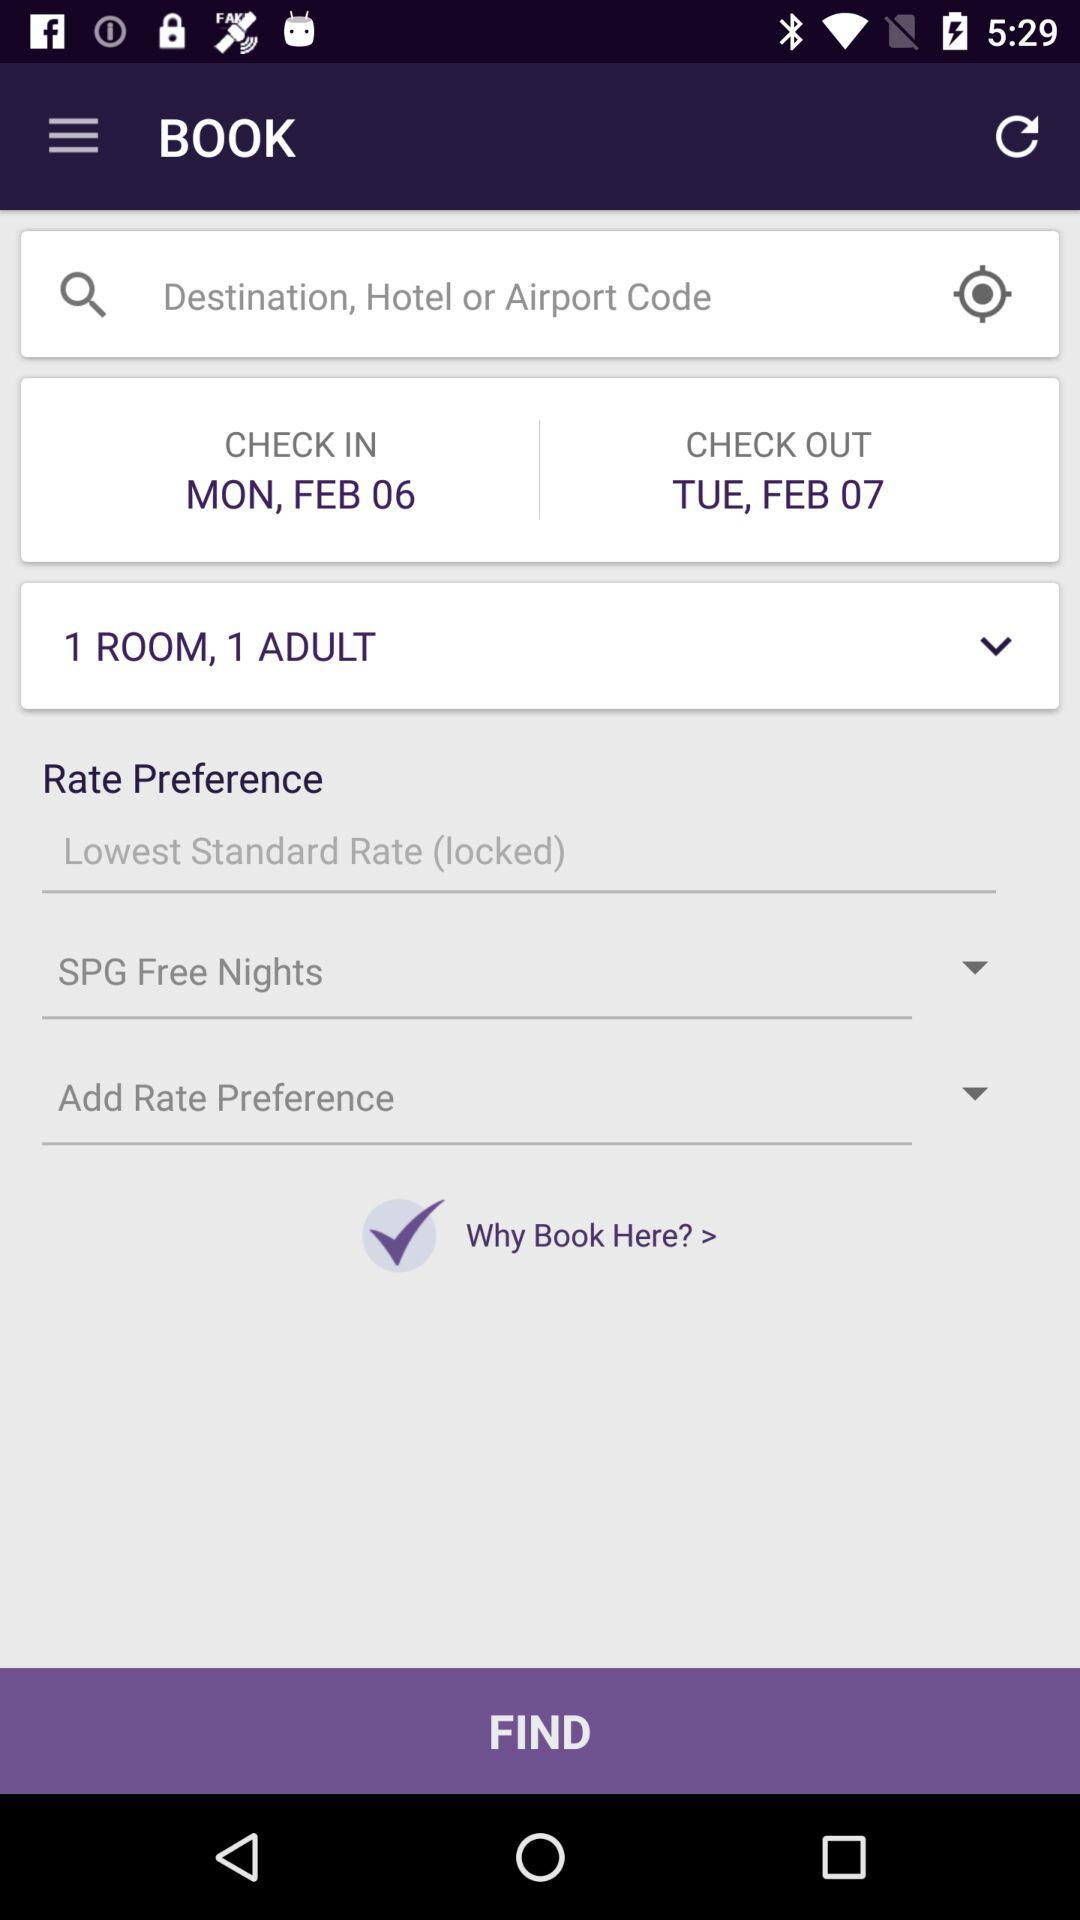What is the entered hotel code?
When the provided information is insufficient, respond with <no answer>. <no answer> 